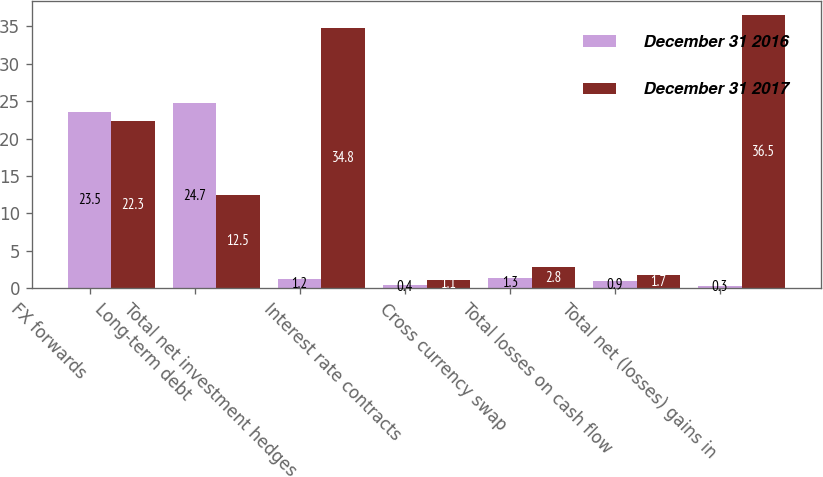<chart> <loc_0><loc_0><loc_500><loc_500><stacked_bar_chart><ecel><fcel>FX forwards<fcel>Long-term debt<fcel>Total net investment hedges<fcel>Interest rate contracts<fcel>Cross currency swap<fcel>Total losses on cash flow<fcel>Total net (losses) gains in<nl><fcel>December 31 2016<fcel>23.5<fcel>24.7<fcel>1.2<fcel>0.4<fcel>1.3<fcel>0.9<fcel>0.3<nl><fcel>December 31 2017<fcel>22.3<fcel>12.5<fcel>34.8<fcel>1.1<fcel>2.8<fcel>1.7<fcel>36.5<nl></chart> 